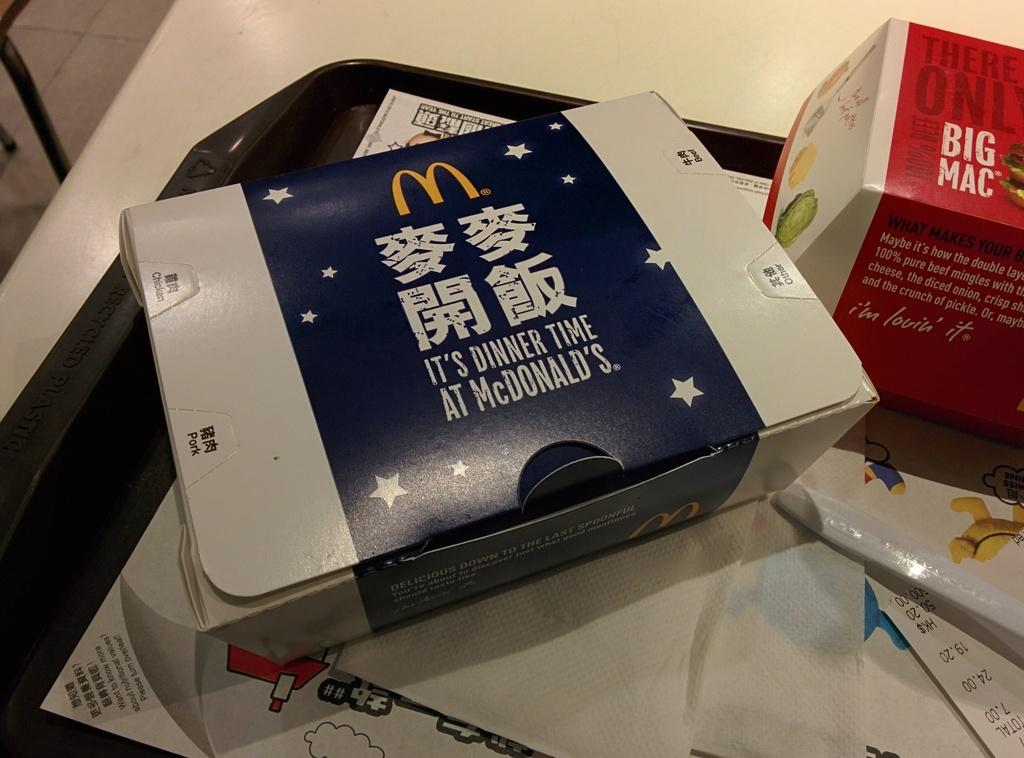<image>
Relay a brief, clear account of the picture shown. A box of McDonalds that says it's dinner time at McDonald's. 